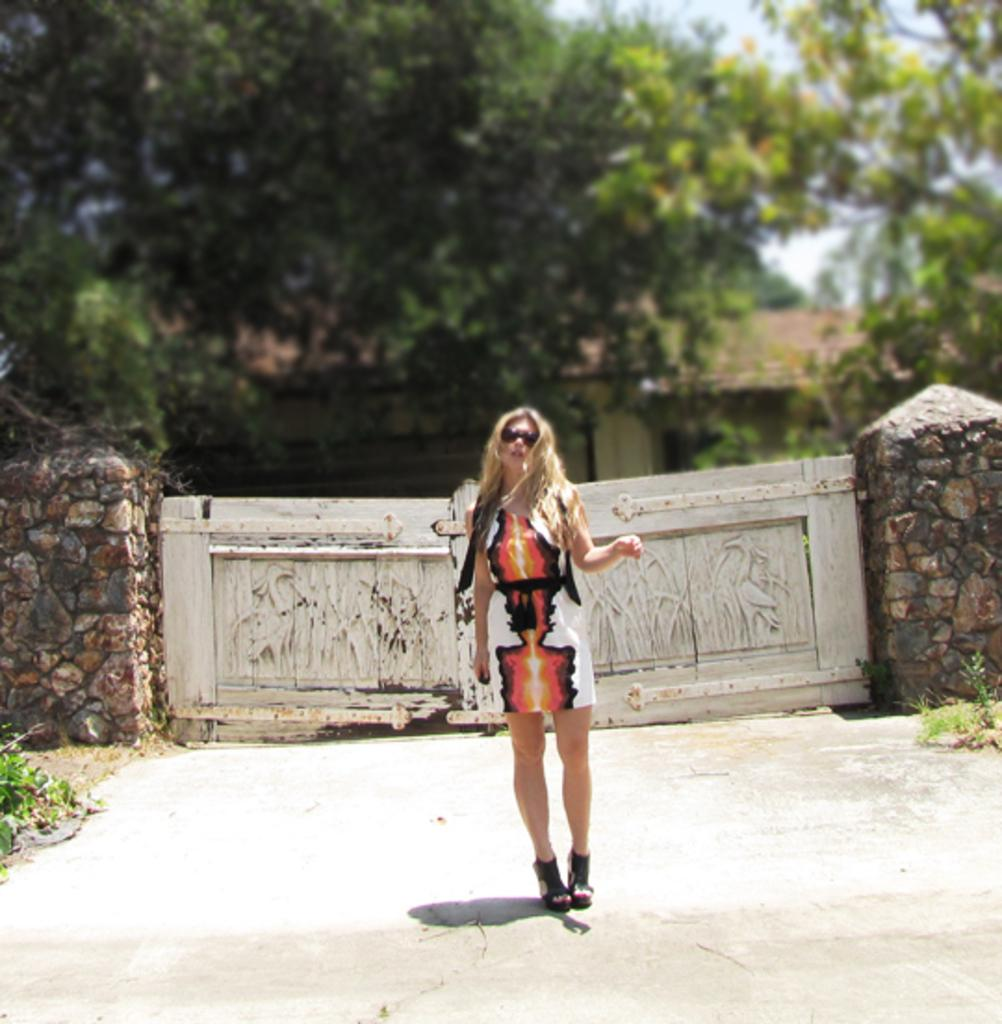What is the main subject of the image? There is a woman standing in the image. What can be seen in the middle of the image? There is a gate in the middle of the image. What is visible in the background of the image? The background of the image is the sky. How many clocks are hanging on the gate in the image? There are no clocks visible on the gate in the image. What type of party is being held in the background of the image? There is no party present in the image; the background is simply the sky. 